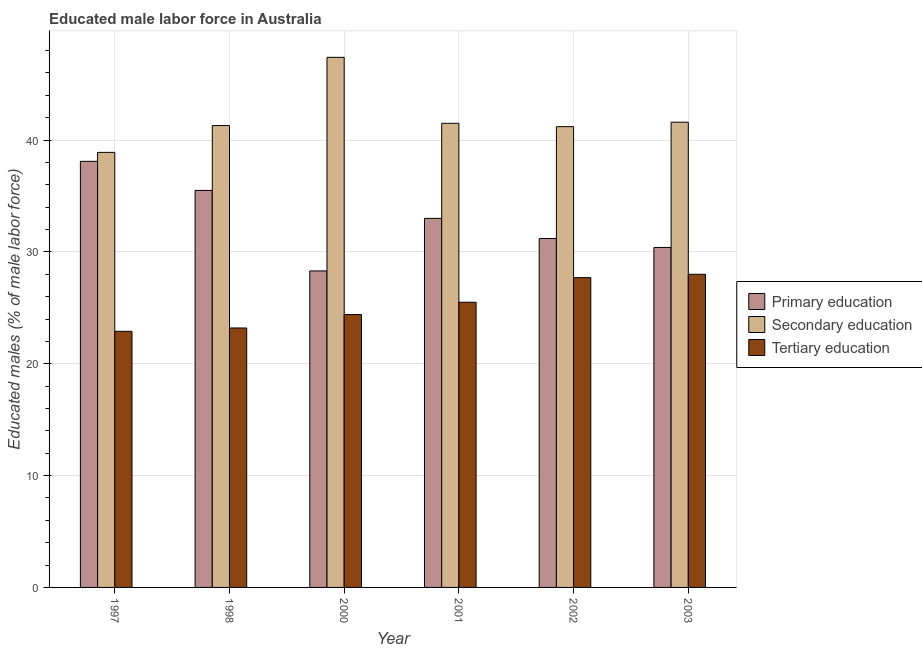How many groups of bars are there?
Provide a short and direct response. 6. How many bars are there on the 4th tick from the left?
Make the answer very short. 3. How many bars are there on the 3rd tick from the right?
Offer a terse response. 3. What is the label of the 6th group of bars from the left?
Your answer should be very brief. 2003. What is the percentage of male labor force who received primary education in 2002?
Your response must be concise. 31.2. Across all years, what is the maximum percentage of male labor force who received tertiary education?
Ensure brevity in your answer.  28. Across all years, what is the minimum percentage of male labor force who received tertiary education?
Offer a terse response. 22.9. In which year was the percentage of male labor force who received primary education maximum?
Your response must be concise. 1997. In which year was the percentage of male labor force who received primary education minimum?
Your response must be concise. 2000. What is the total percentage of male labor force who received tertiary education in the graph?
Your answer should be compact. 151.7. What is the difference between the percentage of male labor force who received primary education in 1998 and that in 2001?
Your answer should be compact. 2.5. What is the difference between the percentage of male labor force who received primary education in 2001 and the percentage of male labor force who received secondary education in 1998?
Keep it short and to the point. -2.5. What is the average percentage of male labor force who received tertiary education per year?
Provide a succinct answer. 25.28. In how many years, is the percentage of male labor force who received primary education greater than 14 %?
Offer a terse response. 6. What is the ratio of the percentage of male labor force who received primary education in 2001 to that in 2002?
Keep it short and to the point. 1.06. Is the percentage of male labor force who received primary education in 2000 less than that in 2001?
Provide a short and direct response. Yes. Is the difference between the percentage of male labor force who received tertiary education in 1998 and 2000 greater than the difference between the percentage of male labor force who received secondary education in 1998 and 2000?
Provide a succinct answer. No. What is the difference between the highest and the second highest percentage of male labor force who received primary education?
Ensure brevity in your answer.  2.6. What is the difference between the highest and the lowest percentage of male labor force who received tertiary education?
Provide a succinct answer. 5.1. In how many years, is the percentage of male labor force who received primary education greater than the average percentage of male labor force who received primary education taken over all years?
Provide a succinct answer. 3. What does the 2nd bar from the left in 2000 represents?
Your response must be concise. Secondary education. What does the 1st bar from the right in 2000 represents?
Your answer should be compact. Tertiary education. Is it the case that in every year, the sum of the percentage of male labor force who received primary education and percentage of male labor force who received secondary education is greater than the percentage of male labor force who received tertiary education?
Your answer should be very brief. Yes. How many bars are there?
Your response must be concise. 18. Are all the bars in the graph horizontal?
Give a very brief answer. No. How many years are there in the graph?
Ensure brevity in your answer.  6. Are the values on the major ticks of Y-axis written in scientific E-notation?
Provide a succinct answer. No. Does the graph contain grids?
Ensure brevity in your answer.  Yes. Where does the legend appear in the graph?
Provide a succinct answer. Center right. How are the legend labels stacked?
Your answer should be compact. Vertical. What is the title of the graph?
Your response must be concise. Educated male labor force in Australia. Does "Coal sources" appear as one of the legend labels in the graph?
Your answer should be compact. No. What is the label or title of the Y-axis?
Your answer should be compact. Educated males (% of male labor force). What is the Educated males (% of male labor force) of Primary education in 1997?
Keep it short and to the point. 38.1. What is the Educated males (% of male labor force) of Secondary education in 1997?
Keep it short and to the point. 38.9. What is the Educated males (% of male labor force) in Tertiary education in 1997?
Your answer should be very brief. 22.9. What is the Educated males (% of male labor force) of Primary education in 1998?
Your answer should be very brief. 35.5. What is the Educated males (% of male labor force) of Secondary education in 1998?
Keep it short and to the point. 41.3. What is the Educated males (% of male labor force) of Tertiary education in 1998?
Give a very brief answer. 23.2. What is the Educated males (% of male labor force) of Primary education in 2000?
Provide a succinct answer. 28.3. What is the Educated males (% of male labor force) in Secondary education in 2000?
Make the answer very short. 47.4. What is the Educated males (% of male labor force) of Tertiary education in 2000?
Keep it short and to the point. 24.4. What is the Educated males (% of male labor force) of Secondary education in 2001?
Your response must be concise. 41.5. What is the Educated males (% of male labor force) of Tertiary education in 2001?
Offer a terse response. 25.5. What is the Educated males (% of male labor force) in Primary education in 2002?
Offer a terse response. 31.2. What is the Educated males (% of male labor force) in Secondary education in 2002?
Ensure brevity in your answer.  41.2. What is the Educated males (% of male labor force) in Tertiary education in 2002?
Offer a terse response. 27.7. What is the Educated males (% of male labor force) of Primary education in 2003?
Offer a terse response. 30.4. What is the Educated males (% of male labor force) in Secondary education in 2003?
Keep it short and to the point. 41.6. What is the Educated males (% of male labor force) in Tertiary education in 2003?
Provide a succinct answer. 28. Across all years, what is the maximum Educated males (% of male labor force) in Primary education?
Offer a terse response. 38.1. Across all years, what is the maximum Educated males (% of male labor force) of Secondary education?
Offer a terse response. 47.4. Across all years, what is the maximum Educated males (% of male labor force) of Tertiary education?
Make the answer very short. 28. Across all years, what is the minimum Educated males (% of male labor force) in Primary education?
Make the answer very short. 28.3. Across all years, what is the minimum Educated males (% of male labor force) of Secondary education?
Provide a succinct answer. 38.9. Across all years, what is the minimum Educated males (% of male labor force) in Tertiary education?
Offer a very short reply. 22.9. What is the total Educated males (% of male labor force) of Primary education in the graph?
Ensure brevity in your answer.  196.5. What is the total Educated males (% of male labor force) in Secondary education in the graph?
Ensure brevity in your answer.  251.9. What is the total Educated males (% of male labor force) in Tertiary education in the graph?
Ensure brevity in your answer.  151.7. What is the difference between the Educated males (% of male labor force) in Primary education in 1997 and that in 2000?
Provide a short and direct response. 9.8. What is the difference between the Educated males (% of male labor force) of Primary education in 1997 and that in 2001?
Ensure brevity in your answer.  5.1. What is the difference between the Educated males (% of male labor force) of Secondary education in 1997 and that in 2001?
Your response must be concise. -2.6. What is the difference between the Educated males (% of male labor force) in Tertiary education in 1997 and that in 2001?
Provide a succinct answer. -2.6. What is the difference between the Educated males (% of male labor force) of Primary education in 1997 and that in 2002?
Ensure brevity in your answer.  6.9. What is the difference between the Educated males (% of male labor force) in Secondary education in 1997 and that in 2002?
Offer a terse response. -2.3. What is the difference between the Educated males (% of male labor force) of Tertiary education in 1997 and that in 2002?
Provide a succinct answer. -4.8. What is the difference between the Educated males (% of male labor force) of Primary education in 1997 and that in 2003?
Your response must be concise. 7.7. What is the difference between the Educated males (% of male labor force) in Tertiary education in 1997 and that in 2003?
Make the answer very short. -5.1. What is the difference between the Educated males (% of male labor force) of Primary education in 1998 and that in 2000?
Offer a terse response. 7.2. What is the difference between the Educated males (% of male labor force) of Secondary education in 1998 and that in 2001?
Your answer should be compact. -0.2. What is the difference between the Educated males (% of male labor force) of Tertiary education in 1998 and that in 2001?
Offer a very short reply. -2.3. What is the difference between the Educated males (% of male labor force) of Primary education in 1998 and that in 2002?
Your response must be concise. 4.3. What is the difference between the Educated males (% of male labor force) in Tertiary education in 1998 and that in 2002?
Make the answer very short. -4.5. What is the difference between the Educated males (% of male labor force) in Secondary education in 1998 and that in 2003?
Make the answer very short. -0.3. What is the difference between the Educated males (% of male labor force) in Secondary education in 2000 and that in 2001?
Give a very brief answer. 5.9. What is the difference between the Educated males (% of male labor force) in Primary education in 2000 and that in 2002?
Provide a succinct answer. -2.9. What is the difference between the Educated males (% of male labor force) of Secondary education in 2000 and that in 2002?
Ensure brevity in your answer.  6.2. What is the difference between the Educated males (% of male labor force) in Primary education in 2000 and that in 2003?
Your answer should be very brief. -2.1. What is the difference between the Educated males (% of male labor force) in Secondary education in 2000 and that in 2003?
Ensure brevity in your answer.  5.8. What is the difference between the Educated males (% of male labor force) of Tertiary education in 2000 and that in 2003?
Your answer should be very brief. -3.6. What is the difference between the Educated males (% of male labor force) of Primary education in 2001 and that in 2002?
Offer a very short reply. 1.8. What is the difference between the Educated males (% of male labor force) in Secondary education in 2001 and that in 2002?
Your response must be concise. 0.3. What is the difference between the Educated males (% of male labor force) in Tertiary education in 2001 and that in 2002?
Provide a short and direct response. -2.2. What is the difference between the Educated males (% of male labor force) in Tertiary education in 2001 and that in 2003?
Give a very brief answer. -2.5. What is the difference between the Educated males (% of male labor force) in Primary education in 1997 and the Educated males (% of male labor force) in Secondary education in 1998?
Make the answer very short. -3.2. What is the difference between the Educated males (% of male labor force) of Primary education in 1997 and the Educated males (% of male labor force) of Secondary education in 2000?
Your answer should be compact. -9.3. What is the difference between the Educated males (% of male labor force) in Primary education in 1997 and the Educated males (% of male labor force) in Tertiary education in 2000?
Make the answer very short. 13.7. What is the difference between the Educated males (% of male labor force) of Secondary education in 1997 and the Educated males (% of male labor force) of Tertiary education in 2000?
Your answer should be very brief. 14.5. What is the difference between the Educated males (% of male labor force) in Primary education in 1997 and the Educated males (% of male labor force) in Secondary education in 2002?
Make the answer very short. -3.1. What is the difference between the Educated males (% of male labor force) in Primary education in 1997 and the Educated males (% of male labor force) in Tertiary education in 2002?
Your answer should be very brief. 10.4. What is the difference between the Educated males (% of male labor force) of Secondary education in 1997 and the Educated males (% of male labor force) of Tertiary education in 2002?
Ensure brevity in your answer.  11.2. What is the difference between the Educated males (% of male labor force) of Primary education in 1997 and the Educated males (% of male labor force) of Secondary education in 2003?
Keep it short and to the point. -3.5. What is the difference between the Educated males (% of male labor force) in Secondary education in 1997 and the Educated males (% of male labor force) in Tertiary education in 2003?
Provide a short and direct response. 10.9. What is the difference between the Educated males (% of male labor force) in Primary education in 1998 and the Educated males (% of male labor force) in Secondary education in 2000?
Your answer should be very brief. -11.9. What is the difference between the Educated males (% of male labor force) of Primary education in 1998 and the Educated males (% of male labor force) of Tertiary education in 2000?
Your answer should be very brief. 11.1. What is the difference between the Educated males (% of male labor force) of Primary education in 1998 and the Educated males (% of male labor force) of Secondary education in 2002?
Offer a terse response. -5.7. What is the difference between the Educated males (% of male labor force) in Secondary education in 1998 and the Educated males (% of male labor force) in Tertiary education in 2002?
Your answer should be compact. 13.6. What is the difference between the Educated males (% of male labor force) of Secondary education in 1998 and the Educated males (% of male labor force) of Tertiary education in 2003?
Make the answer very short. 13.3. What is the difference between the Educated males (% of male labor force) in Secondary education in 2000 and the Educated males (% of male labor force) in Tertiary education in 2001?
Ensure brevity in your answer.  21.9. What is the difference between the Educated males (% of male labor force) in Primary education in 2000 and the Educated males (% of male labor force) in Secondary education in 2003?
Ensure brevity in your answer.  -13.3. What is the difference between the Educated males (% of male labor force) in Secondary education in 2001 and the Educated males (% of male labor force) in Tertiary education in 2002?
Your answer should be very brief. 13.8. What is the difference between the Educated males (% of male labor force) of Primary education in 2001 and the Educated males (% of male labor force) of Secondary education in 2003?
Give a very brief answer. -8.6. What is the difference between the Educated males (% of male labor force) in Primary education in 2001 and the Educated males (% of male labor force) in Tertiary education in 2003?
Keep it short and to the point. 5. What is the difference between the Educated males (% of male labor force) of Secondary education in 2001 and the Educated males (% of male labor force) of Tertiary education in 2003?
Offer a very short reply. 13.5. What is the difference between the Educated males (% of male labor force) in Secondary education in 2002 and the Educated males (% of male labor force) in Tertiary education in 2003?
Your response must be concise. 13.2. What is the average Educated males (% of male labor force) of Primary education per year?
Provide a short and direct response. 32.75. What is the average Educated males (% of male labor force) of Secondary education per year?
Provide a short and direct response. 41.98. What is the average Educated males (% of male labor force) in Tertiary education per year?
Offer a terse response. 25.28. In the year 1997, what is the difference between the Educated males (% of male labor force) of Primary education and Educated males (% of male labor force) of Secondary education?
Give a very brief answer. -0.8. In the year 1997, what is the difference between the Educated males (% of male labor force) of Primary education and Educated males (% of male labor force) of Tertiary education?
Your answer should be compact. 15.2. In the year 1997, what is the difference between the Educated males (% of male labor force) of Secondary education and Educated males (% of male labor force) of Tertiary education?
Your response must be concise. 16. In the year 1998, what is the difference between the Educated males (% of male labor force) of Primary education and Educated males (% of male labor force) of Tertiary education?
Offer a very short reply. 12.3. In the year 1998, what is the difference between the Educated males (% of male labor force) in Secondary education and Educated males (% of male labor force) in Tertiary education?
Keep it short and to the point. 18.1. In the year 2000, what is the difference between the Educated males (% of male labor force) in Primary education and Educated males (% of male labor force) in Secondary education?
Your answer should be very brief. -19.1. In the year 2000, what is the difference between the Educated males (% of male labor force) in Secondary education and Educated males (% of male labor force) in Tertiary education?
Make the answer very short. 23. In the year 2001, what is the difference between the Educated males (% of male labor force) of Primary education and Educated males (% of male labor force) of Tertiary education?
Your answer should be compact. 7.5. In the year 2001, what is the difference between the Educated males (% of male labor force) of Secondary education and Educated males (% of male labor force) of Tertiary education?
Your answer should be compact. 16. In the year 2002, what is the difference between the Educated males (% of male labor force) of Primary education and Educated males (% of male labor force) of Secondary education?
Make the answer very short. -10. In the year 2003, what is the difference between the Educated males (% of male labor force) of Primary education and Educated males (% of male labor force) of Tertiary education?
Your response must be concise. 2.4. What is the ratio of the Educated males (% of male labor force) of Primary education in 1997 to that in 1998?
Your answer should be compact. 1.07. What is the ratio of the Educated males (% of male labor force) in Secondary education in 1997 to that in 1998?
Provide a short and direct response. 0.94. What is the ratio of the Educated males (% of male labor force) in Tertiary education in 1997 to that in 1998?
Provide a short and direct response. 0.99. What is the ratio of the Educated males (% of male labor force) in Primary education in 1997 to that in 2000?
Make the answer very short. 1.35. What is the ratio of the Educated males (% of male labor force) of Secondary education in 1997 to that in 2000?
Your answer should be compact. 0.82. What is the ratio of the Educated males (% of male labor force) of Tertiary education in 1997 to that in 2000?
Your answer should be compact. 0.94. What is the ratio of the Educated males (% of male labor force) in Primary education in 1997 to that in 2001?
Make the answer very short. 1.15. What is the ratio of the Educated males (% of male labor force) in Secondary education in 1997 to that in 2001?
Offer a terse response. 0.94. What is the ratio of the Educated males (% of male labor force) of Tertiary education in 1997 to that in 2001?
Offer a very short reply. 0.9. What is the ratio of the Educated males (% of male labor force) in Primary education in 1997 to that in 2002?
Make the answer very short. 1.22. What is the ratio of the Educated males (% of male labor force) in Secondary education in 1997 to that in 2002?
Make the answer very short. 0.94. What is the ratio of the Educated males (% of male labor force) of Tertiary education in 1997 to that in 2002?
Provide a succinct answer. 0.83. What is the ratio of the Educated males (% of male labor force) in Primary education in 1997 to that in 2003?
Make the answer very short. 1.25. What is the ratio of the Educated males (% of male labor force) in Secondary education in 1997 to that in 2003?
Offer a terse response. 0.94. What is the ratio of the Educated males (% of male labor force) in Tertiary education in 1997 to that in 2003?
Provide a succinct answer. 0.82. What is the ratio of the Educated males (% of male labor force) in Primary education in 1998 to that in 2000?
Offer a terse response. 1.25. What is the ratio of the Educated males (% of male labor force) of Secondary education in 1998 to that in 2000?
Your answer should be very brief. 0.87. What is the ratio of the Educated males (% of male labor force) of Tertiary education in 1998 to that in 2000?
Your answer should be very brief. 0.95. What is the ratio of the Educated males (% of male labor force) of Primary education in 1998 to that in 2001?
Your response must be concise. 1.08. What is the ratio of the Educated males (% of male labor force) in Tertiary education in 1998 to that in 2001?
Keep it short and to the point. 0.91. What is the ratio of the Educated males (% of male labor force) of Primary education in 1998 to that in 2002?
Offer a terse response. 1.14. What is the ratio of the Educated males (% of male labor force) in Tertiary education in 1998 to that in 2002?
Offer a terse response. 0.84. What is the ratio of the Educated males (% of male labor force) of Primary education in 1998 to that in 2003?
Make the answer very short. 1.17. What is the ratio of the Educated males (% of male labor force) in Tertiary education in 1998 to that in 2003?
Provide a succinct answer. 0.83. What is the ratio of the Educated males (% of male labor force) of Primary education in 2000 to that in 2001?
Your answer should be compact. 0.86. What is the ratio of the Educated males (% of male labor force) of Secondary education in 2000 to that in 2001?
Make the answer very short. 1.14. What is the ratio of the Educated males (% of male labor force) of Tertiary education in 2000 to that in 2001?
Make the answer very short. 0.96. What is the ratio of the Educated males (% of male labor force) of Primary education in 2000 to that in 2002?
Keep it short and to the point. 0.91. What is the ratio of the Educated males (% of male labor force) in Secondary education in 2000 to that in 2002?
Provide a short and direct response. 1.15. What is the ratio of the Educated males (% of male labor force) in Tertiary education in 2000 to that in 2002?
Your response must be concise. 0.88. What is the ratio of the Educated males (% of male labor force) of Primary education in 2000 to that in 2003?
Provide a succinct answer. 0.93. What is the ratio of the Educated males (% of male labor force) in Secondary education in 2000 to that in 2003?
Your answer should be compact. 1.14. What is the ratio of the Educated males (% of male labor force) in Tertiary education in 2000 to that in 2003?
Provide a short and direct response. 0.87. What is the ratio of the Educated males (% of male labor force) in Primary education in 2001 to that in 2002?
Offer a terse response. 1.06. What is the ratio of the Educated males (% of male labor force) in Secondary education in 2001 to that in 2002?
Your answer should be very brief. 1.01. What is the ratio of the Educated males (% of male labor force) in Tertiary education in 2001 to that in 2002?
Keep it short and to the point. 0.92. What is the ratio of the Educated males (% of male labor force) of Primary education in 2001 to that in 2003?
Provide a succinct answer. 1.09. What is the ratio of the Educated males (% of male labor force) of Secondary education in 2001 to that in 2003?
Give a very brief answer. 1. What is the ratio of the Educated males (% of male labor force) of Tertiary education in 2001 to that in 2003?
Your response must be concise. 0.91. What is the ratio of the Educated males (% of male labor force) in Primary education in 2002 to that in 2003?
Keep it short and to the point. 1.03. What is the ratio of the Educated males (% of male labor force) of Tertiary education in 2002 to that in 2003?
Your response must be concise. 0.99. What is the difference between the highest and the second highest Educated males (% of male labor force) in Primary education?
Keep it short and to the point. 2.6. What is the difference between the highest and the lowest Educated males (% of male labor force) in Secondary education?
Your answer should be very brief. 8.5. 